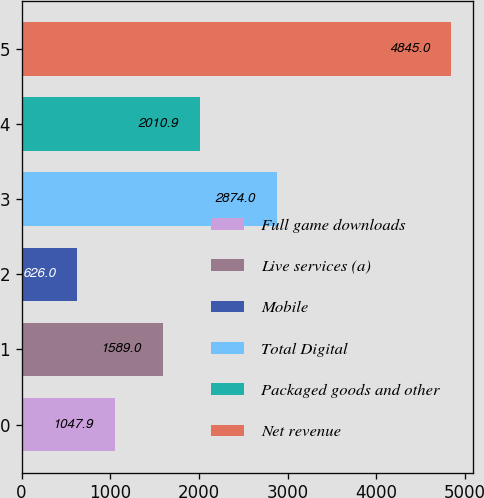Convert chart to OTSL. <chart><loc_0><loc_0><loc_500><loc_500><bar_chart><fcel>Full game downloads<fcel>Live services (a)<fcel>Mobile<fcel>Total Digital<fcel>Packaged goods and other<fcel>Net revenue<nl><fcel>1047.9<fcel>1589<fcel>626<fcel>2874<fcel>2010.9<fcel>4845<nl></chart> 